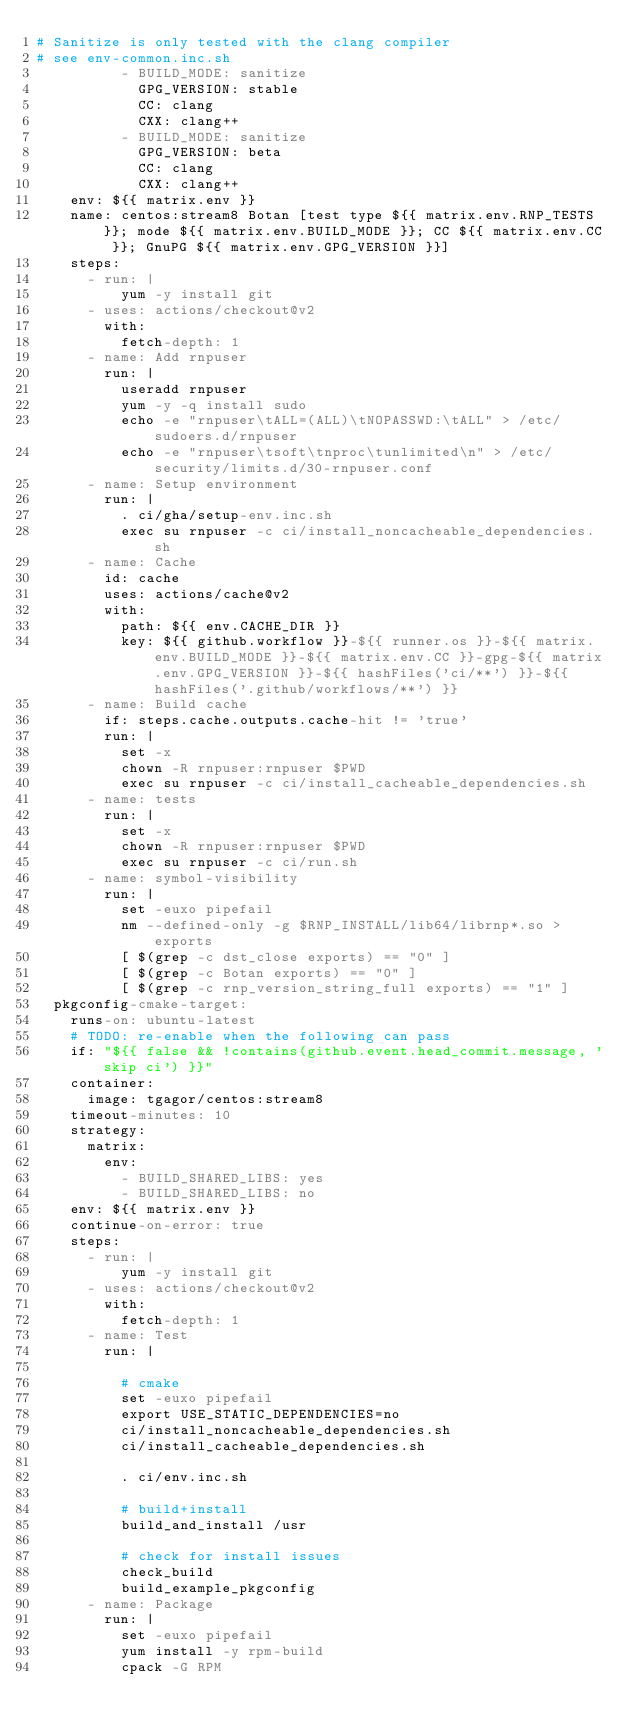Convert code to text. <code><loc_0><loc_0><loc_500><loc_500><_YAML_># Sanitize is only tested with the clang compiler
# see env-common.inc.sh
          - BUILD_MODE: sanitize
            GPG_VERSION: stable
            CC: clang
            CXX: clang++
          - BUILD_MODE: sanitize
            GPG_VERSION: beta
            CC: clang
            CXX: clang++
    env: ${{ matrix.env }}
    name: centos:stream8 Botan [test type ${{ matrix.env.RNP_TESTS }}; mode ${{ matrix.env.BUILD_MODE }}; CC ${{ matrix.env.CC }}; GnuPG ${{ matrix.env.GPG_VERSION }}]
    steps:
      - run: |
          yum -y install git
      - uses: actions/checkout@v2
        with:
          fetch-depth: 1
      - name: Add rnpuser
        run: |
          useradd rnpuser
          yum -y -q install sudo
          echo -e "rnpuser\tALL=(ALL)\tNOPASSWD:\tALL" > /etc/sudoers.d/rnpuser
          echo -e "rnpuser\tsoft\tnproc\tunlimited\n" > /etc/security/limits.d/30-rnpuser.conf
      - name: Setup environment
        run: |
          . ci/gha/setup-env.inc.sh
          exec su rnpuser -c ci/install_noncacheable_dependencies.sh
      - name: Cache
        id: cache
        uses: actions/cache@v2
        with:
          path: ${{ env.CACHE_DIR }}
          key: ${{ github.workflow }}-${{ runner.os }}-${{ matrix.env.BUILD_MODE }}-${{ matrix.env.CC }}-gpg-${{ matrix.env.GPG_VERSION }}-${{ hashFiles('ci/**') }}-${{ hashFiles('.github/workflows/**') }}
      - name: Build cache
        if: steps.cache.outputs.cache-hit != 'true'
        run: |
          set -x
          chown -R rnpuser:rnpuser $PWD
          exec su rnpuser -c ci/install_cacheable_dependencies.sh
      - name: tests
        run: |
          set -x
          chown -R rnpuser:rnpuser $PWD
          exec su rnpuser -c ci/run.sh
      - name: symbol-visibility
        run: |
          set -euxo pipefail
          nm --defined-only -g $RNP_INSTALL/lib64/librnp*.so > exports
          [ $(grep -c dst_close exports) == "0" ]
          [ $(grep -c Botan exports) == "0" ]
          [ $(grep -c rnp_version_string_full exports) == "1" ]
  pkgconfig-cmake-target:
    runs-on: ubuntu-latest
    # TODO: re-enable when the following can pass
    if: "${{ false && !contains(github.event.head_commit.message, 'skip ci') }}"
    container:
      image: tgagor/centos:stream8
    timeout-minutes: 10
    strategy:
      matrix:
        env:
          - BUILD_SHARED_LIBS: yes
          - BUILD_SHARED_LIBS: no
    env: ${{ matrix.env }}
    continue-on-error: true
    steps:
      - run: |
          yum -y install git
      - uses: actions/checkout@v2
        with:
          fetch-depth: 1
      - name: Test
        run: |

          # cmake
          set -euxo pipefail
          export USE_STATIC_DEPENDENCIES=no
          ci/install_noncacheable_dependencies.sh
          ci/install_cacheable_dependencies.sh

          . ci/env.inc.sh

          # build+install
          build_and_install /usr

          # check for install issues
          check_build
          build_example_pkgconfig
      - name: Package
        run: |
          set -euxo pipefail
          yum install -y rpm-build
          cpack -G RPM
</code> 